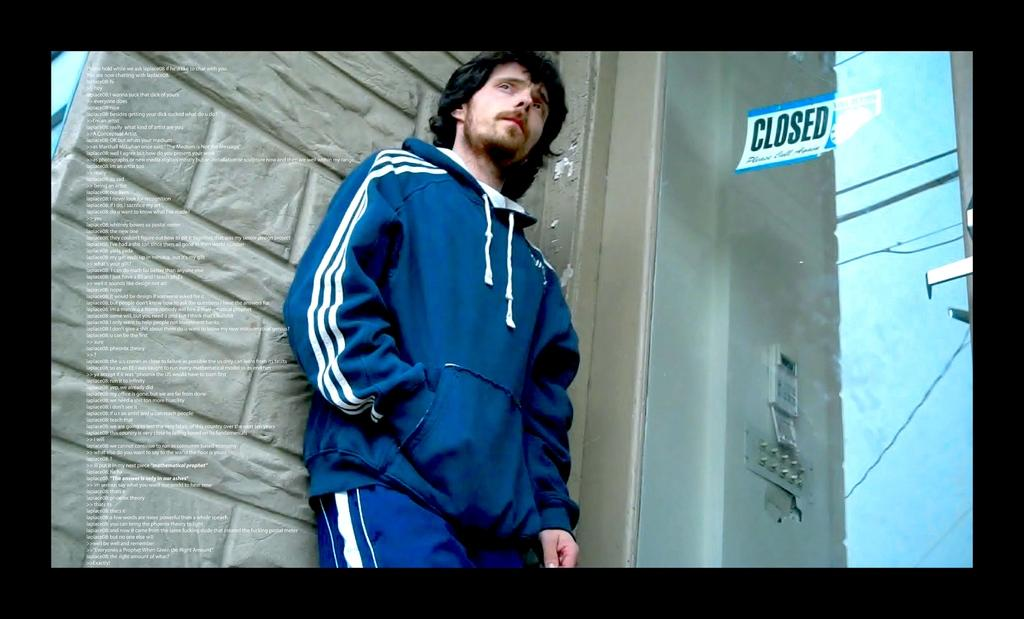<image>
Provide a brief description of the given image. A man stands in front of a glass window that has a closed sign on the other side of it. 